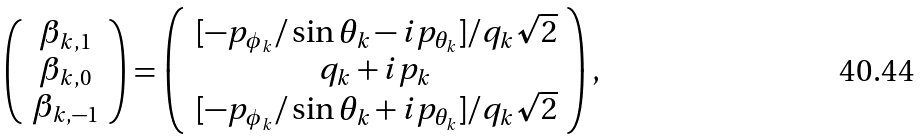<formula> <loc_0><loc_0><loc_500><loc_500>\left ( \begin{array} { c } \beta _ { k , 1 } \\ \beta _ { k , 0 } \\ \beta _ { k , - 1 } \end{array} \right ) = \left ( \begin{array} { c } \, [ - p _ { \phi _ { k } } / \sin \theta _ { k } - i p _ { \theta _ { k } } ] / q _ { k } \sqrt { 2 } \\ q _ { k } + i p _ { k } \\ \, [ - p _ { \phi _ { k } } / \sin \theta _ { k } + i p _ { \theta _ { k } } ] / q _ { k } \sqrt { 2 } \end{array} \right ) ,</formula> 